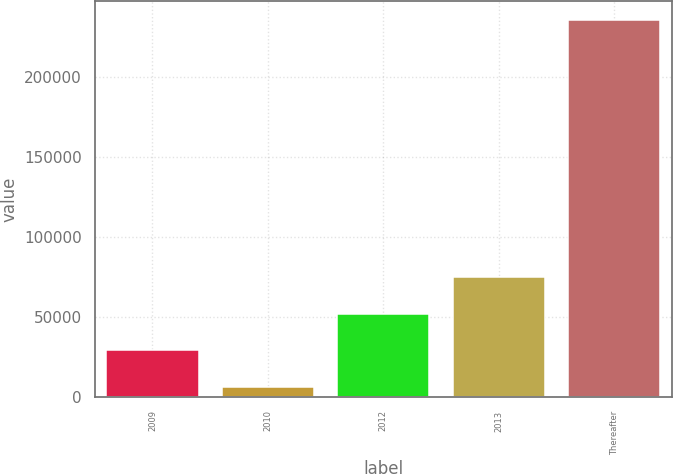Convert chart to OTSL. <chart><loc_0><loc_0><loc_500><loc_500><bar_chart><fcel>2009<fcel>2010<fcel>2012<fcel>2013<fcel>Thereafter<nl><fcel>29210.4<fcel>6321<fcel>52099.8<fcel>74989.2<fcel>235215<nl></chart> 